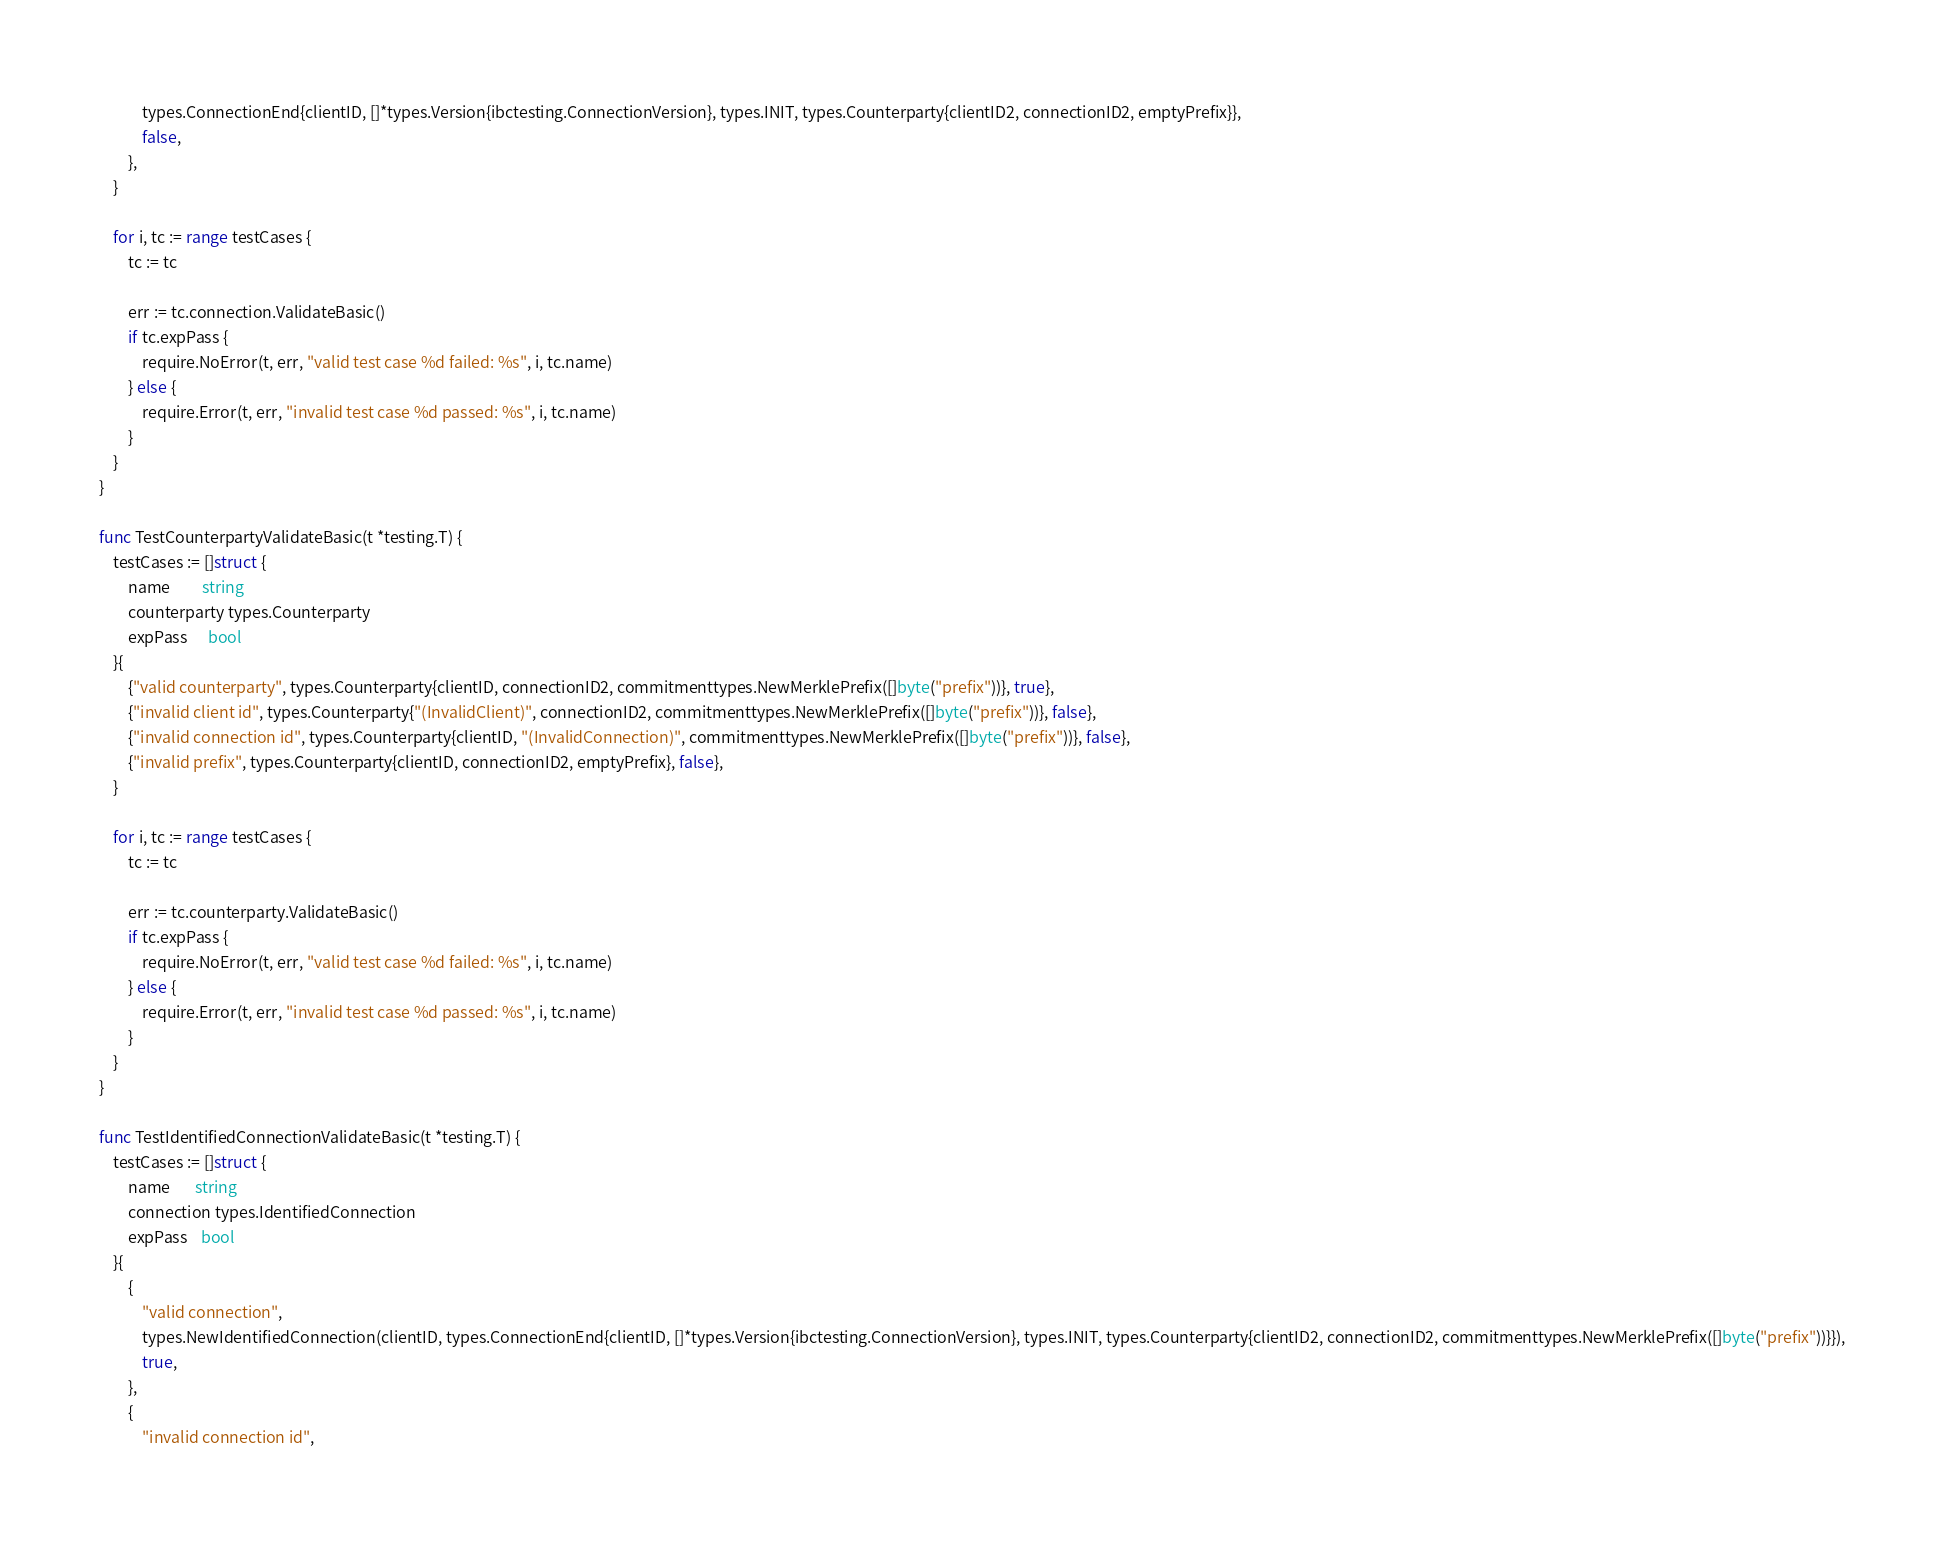<code> <loc_0><loc_0><loc_500><loc_500><_Go_>			types.ConnectionEnd{clientID, []*types.Version{ibctesting.ConnectionVersion}, types.INIT, types.Counterparty{clientID2, connectionID2, emptyPrefix}},
			false,
		},
	}

	for i, tc := range testCases {
		tc := tc

		err := tc.connection.ValidateBasic()
		if tc.expPass {
			require.NoError(t, err, "valid test case %d failed: %s", i, tc.name)
		} else {
			require.Error(t, err, "invalid test case %d passed: %s", i, tc.name)
		}
	}
}

func TestCounterpartyValidateBasic(t *testing.T) {
	testCases := []struct {
		name         string
		counterparty types.Counterparty
		expPass      bool
	}{
		{"valid counterparty", types.Counterparty{clientID, connectionID2, commitmenttypes.NewMerklePrefix([]byte("prefix"))}, true},
		{"invalid client id", types.Counterparty{"(InvalidClient)", connectionID2, commitmenttypes.NewMerklePrefix([]byte("prefix"))}, false},
		{"invalid connection id", types.Counterparty{clientID, "(InvalidConnection)", commitmenttypes.NewMerklePrefix([]byte("prefix"))}, false},
		{"invalid prefix", types.Counterparty{clientID, connectionID2, emptyPrefix}, false},
	}

	for i, tc := range testCases {
		tc := tc

		err := tc.counterparty.ValidateBasic()
		if tc.expPass {
			require.NoError(t, err, "valid test case %d failed: %s", i, tc.name)
		} else {
			require.Error(t, err, "invalid test case %d passed: %s", i, tc.name)
		}
	}
}

func TestIdentifiedConnectionValidateBasic(t *testing.T) {
	testCases := []struct {
		name       string
		connection types.IdentifiedConnection
		expPass    bool
	}{
		{
			"valid connection",
			types.NewIdentifiedConnection(clientID, types.ConnectionEnd{clientID, []*types.Version{ibctesting.ConnectionVersion}, types.INIT, types.Counterparty{clientID2, connectionID2, commitmenttypes.NewMerklePrefix([]byte("prefix"))}}),
			true,
		},
		{
			"invalid connection id",</code> 